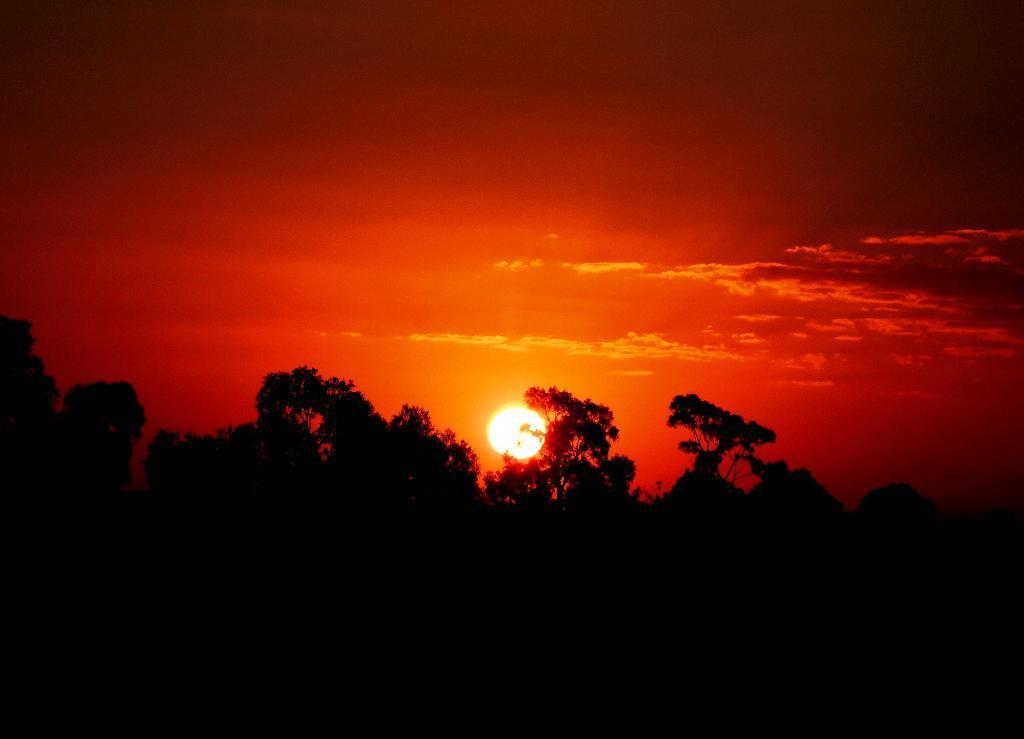How would you summarize this image in a sentence or two? At the bottom of the picture, we see trees and it is black in color. In the background, we see the sun and the sky, which is red in color. This picture is clicked at the time of sunset. 